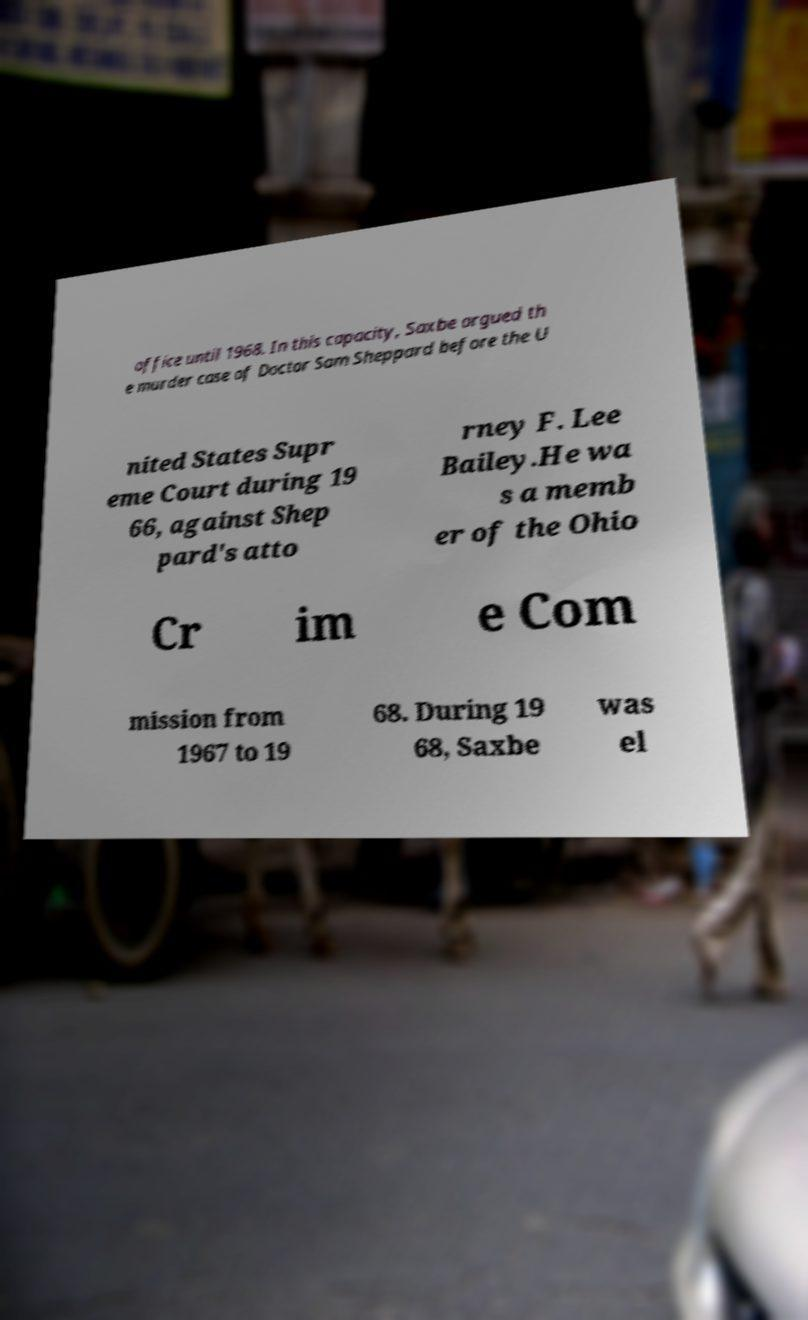Can you accurately transcribe the text from the provided image for me? office until 1968. In this capacity, Saxbe argued th e murder case of Doctor Sam Sheppard before the U nited States Supr eme Court during 19 66, against Shep pard's atto rney F. Lee Bailey.He wa s a memb er of the Ohio Cr im e Com mission from 1967 to 19 68. During 19 68, Saxbe was el 